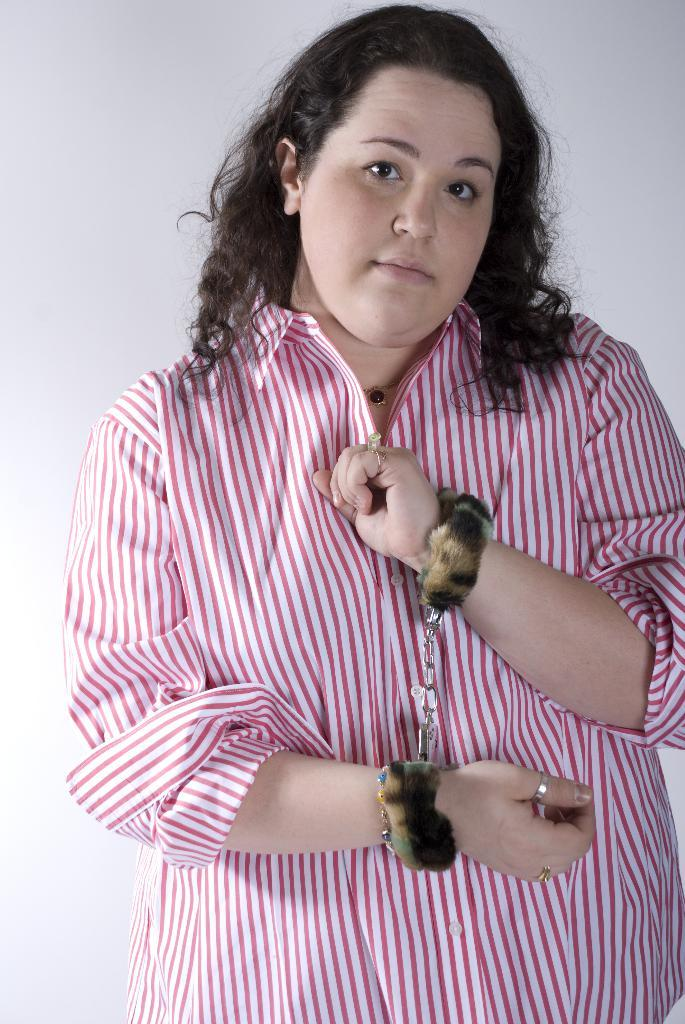What is the main subject of the image? There is a beautiful woman in the image. What is the woman holding in the image? The woman is showing handcuffs. What type of clothing is the woman wearing? The woman is wearing a shirt. What type of jewel is the woman wearing on her wrist in the image? There is no mention of a jewel in the image; the woman is showing handcuffs. 